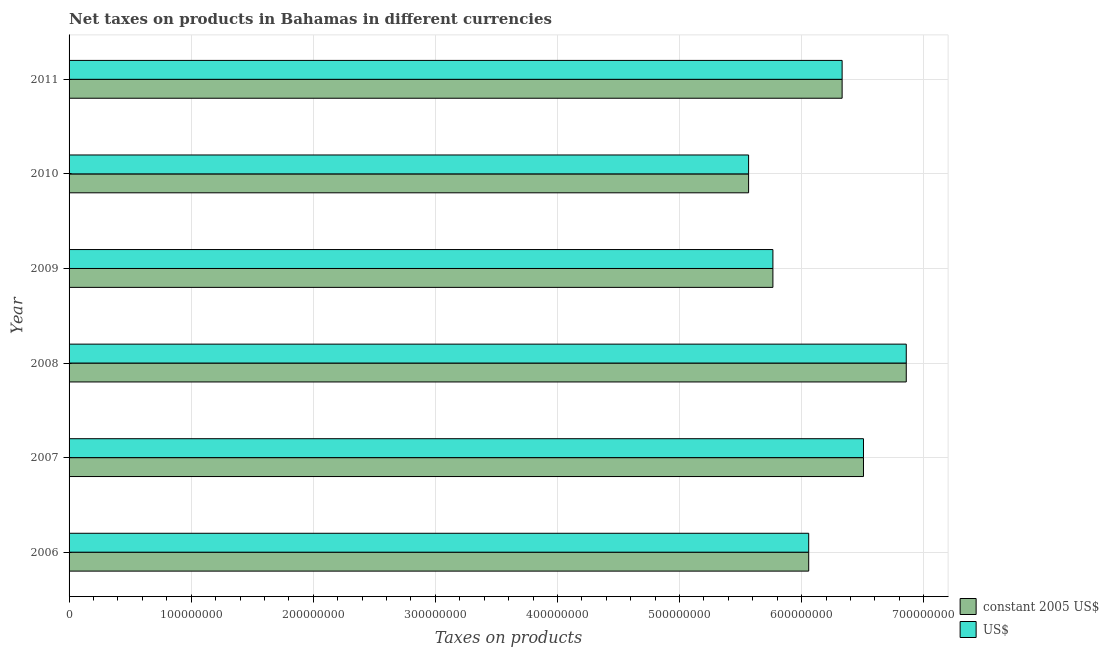Are the number of bars on each tick of the Y-axis equal?
Provide a succinct answer. Yes. How many bars are there on the 6th tick from the top?
Ensure brevity in your answer.  2. How many bars are there on the 3rd tick from the bottom?
Provide a succinct answer. 2. What is the net taxes in constant 2005 us$ in 2007?
Make the answer very short. 6.51e+08. Across all years, what is the maximum net taxes in us$?
Your response must be concise. 6.86e+08. Across all years, what is the minimum net taxes in us$?
Make the answer very short. 5.57e+08. In which year was the net taxes in us$ maximum?
Your answer should be compact. 2008. In which year was the net taxes in us$ minimum?
Keep it short and to the point. 2010. What is the total net taxes in constant 2005 us$ in the graph?
Your answer should be very brief. 3.71e+09. What is the difference between the net taxes in constant 2005 us$ in 2010 and that in 2011?
Offer a very short reply. -7.66e+07. What is the difference between the net taxes in us$ in 2008 and the net taxes in constant 2005 us$ in 2007?
Keep it short and to the point. 3.50e+07. What is the average net taxes in constant 2005 us$ per year?
Your answer should be very brief. 6.18e+08. What is the ratio of the net taxes in constant 2005 us$ in 2006 to that in 2007?
Your answer should be very brief. 0.93. Is the net taxes in us$ in 2008 less than that in 2009?
Your answer should be compact. No. Is the difference between the net taxes in us$ in 2009 and 2010 greater than the difference between the net taxes in constant 2005 us$ in 2009 and 2010?
Ensure brevity in your answer.  No. What is the difference between the highest and the second highest net taxes in us$?
Keep it short and to the point. 3.50e+07. What is the difference between the highest and the lowest net taxes in constant 2005 us$?
Ensure brevity in your answer.  1.29e+08. Is the sum of the net taxes in us$ in 2006 and 2007 greater than the maximum net taxes in constant 2005 us$ across all years?
Your answer should be compact. Yes. What does the 1st bar from the top in 2008 represents?
Ensure brevity in your answer.  US$. What does the 2nd bar from the bottom in 2006 represents?
Provide a succinct answer. US$. How many bars are there?
Your response must be concise. 12. How many years are there in the graph?
Ensure brevity in your answer.  6. What is the difference between two consecutive major ticks on the X-axis?
Offer a very short reply. 1.00e+08. Are the values on the major ticks of X-axis written in scientific E-notation?
Your answer should be very brief. No. Does the graph contain grids?
Keep it short and to the point. Yes. How many legend labels are there?
Provide a succinct answer. 2. What is the title of the graph?
Offer a terse response. Net taxes on products in Bahamas in different currencies. What is the label or title of the X-axis?
Provide a short and direct response. Taxes on products. What is the Taxes on products of constant 2005 US$ in 2006?
Offer a very short reply. 6.06e+08. What is the Taxes on products in US$ in 2006?
Give a very brief answer. 6.06e+08. What is the Taxes on products of constant 2005 US$ in 2007?
Make the answer very short. 6.51e+08. What is the Taxes on products of US$ in 2007?
Provide a succinct answer. 6.51e+08. What is the Taxes on products in constant 2005 US$ in 2008?
Ensure brevity in your answer.  6.86e+08. What is the Taxes on products of US$ in 2008?
Your answer should be very brief. 6.86e+08. What is the Taxes on products in constant 2005 US$ in 2009?
Give a very brief answer. 5.76e+08. What is the Taxes on products of US$ in 2009?
Ensure brevity in your answer.  5.76e+08. What is the Taxes on products in constant 2005 US$ in 2010?
Provide a short and direct response. 5.57e+08. What is the Taxes on products of US$ in 2010?
Your response must be concise. 5.57e+08. What is the Taxes on products of constant 2005 US$ in 2011?
Your answer should be compact. 6.33e+08. What is the Taxes on products in US$ in 2011?
Keep it short and to the point. 6.33e+08. Across all years, what is the maximum Taxes on products of constant 2005 US$?
Offer a terse response. 6.86e+08. Across all years, what is the maximum Taxes on products in US$?
Ensure brevity in your answer.  6.86e+08. Across all years, what is the minimum Taxes on products in constant 2005 US$?
Your answer should be compact. 5.57e+08. Across all years, what is the minimum Taxes on products in US$?
Make the answer very short. 5.57e+08. What is the total Taxes on products of constant 2005 US$ in the graph?
Keep it short and to the point. 3.71e+09. What is the total Taxes on products of US$ in the graph?
Give a very brief answer. 3.71e+09. What is the difference between the Taxes on products in constant 2005 US$ in 2006 and that in 2007?
Give a very brief answer. -4.49e+07. What is the difference between the Taxes on products in US$ in 2006 and that in 2007?
Your answer should be very brief. -4.49e+07. What is the difference between the Taxes on products in constant 2005 US$ in 2006 and that in 2008?
Your answer should be very brief. -7.99e+07. What is the difference between the Taxes on products of US$ in 2006 and that in 2008?
Provide a succinct answer. -7.99e+07. What is the difference between the Taxes on products of constant 2005 US$ in 2006 and that in 2009?
Your answer should be very brief. 2.93e+07. What is the difference between the Taxes on products in US$ in 2006 and that in 2009?
Give a very brief answer. 2.93e+07. What is the difference between the Taxes on products in constant 2005 US$ in 2006 and that in 2010?
Your response must be concise. 4.92e+07. What is the difference between the Taxes on products of US$ in 2006 and that in 2010?
Give a very brief answer. 4.92e+07. What is the difference between the Taxes on products in constant 2005 US$ in 2006 and that in 2011?
Make the answer very short. -2.74e+07. What is the difference between the Taxes on products of US$ in 2006 and that in 2011?
Offer a very short reply. -2.74e+07. What is the difference between the Taxes on products of constant 2005 US$ in 2007 and that in 2008?
Offer a terse response. -3.50e+07. What is the difference between the Taxes on products of US$ in 2007 and that in 2008?
Your answer should be very brief. -3.50e+07. What is the difference between the Taxes on products of constant 2005 US$ in 2007 and that in 2009?
Ensure brevity in your answer.  7.42e+07. What is the difference between the Taxes on products of US$ in 2007 and that in 2009?
Offer a very short reply. 7.42e+07. What is the difference between the Taxes on products in constant 2005 US$ in 2007 and that in 2010?
Give a very brief answer. 9.41e+07. What is the difference between the Taxes on products of US$ in 2007 and that in 2010?
Your answer should be compact. 9.41e+07. What is the difference between the Taxes on products of constant 2005 US$ in 2007 and that in 2011?
Provide a succinct answer. 1.75e+07. What is the difference between the Taxes on products of US$ in 2007 and that in 2011?
Offer a terse response. 1.75e+07. What is the difference between the Taxes on products of constant 2005 US$ in 2008 and that in 2009?
Provide a succinct answer. 1.09e+08. What is the difference between the Taxes on products in US$ in 2008 and that in 2009?
Keep it short and to the point. 1.09e+08. What is the difference between the Taxes on products of constant 2005 US$ in 2008 and that in 2010?
Your response must be concise. 1.29e+08. What is the difference between the Taxes on products of US$ in 2008 and that in 2010?
Your response must be concise. 1.29e+08. What is the difference between the Taxes on products in constant 2005 US$ in 2008 and that in 2011?
Make the answer very short. 5.25e+07. What is the difference between the Taxes on products of US$ in 2008 and that in 2011?
Give a very brief answer. 5.25e+07. What is the difference between the Taxes on products of constant 2005 US$ in 2009 and that in 2010?
Give a very brief answer. 1.99e+07. What is the difference between the Taxes on products in US$ in 2009 and that in 2010?
Keep it short and to the point. 1.99e+07. What is the difference between the Taxes on products in constant 2005 US$ in 2009 and that in 2011?
Offer a very short reply. -5.67e+07. What is the difference between the Taxes on products of US$ in 2009 and that in 2011?
Provide a succinct answer. -5.67e+07. What is the difference between the Taxes on products in constant 2005 US$ in 2010 and that in 2011?
Ensure brevity in your answer.  -7.66e+07. What is the difference between the Taxes on products in US$ in 2010 and that in 2011?
Provide a short and direct response. -7.66e+07. What is the difference between the Taxes on products of constant 2005 US$ in 2006 and the Taxes on products of US$ in 2007?
Give a very brief answer. -4.49e+07. What is the difference between the Taxes on products of constant 2005 US$ in 2006 and the Taxes on products of US$ in 2008?
Offer a very short reply. -7.99e+07. What is the difference between the Taxes on products of constant 2005 US$ in 2006 and the Taxes on products of US$ in 2009?
Make the answer very short. 2.93e+07. What is the difference between the Taxes on products of constant 2005 US$ in 2006 and the Taxes on products of US$ in 2010?
Provide a short and direct response. 4.92e+07. What is the difference between the Taxes on products of constant 2005 US$ in 2006 and the Taxes on products of US$ in 2011?
Offer a terse response. -2.74e+07. What is the difference between the Taxes on products of constant 2005 US$ in 2007 and the Taxes on products of US$ in 2008?
Make the answer very short. -3.50e+07. What is the difference between the Taxes on products of constant 2005 US$ in 2007 and the Taxes on products of US$ in 2009?
Your answer should be very brief. 7.42e+07. What is the difference between the Taxes on products in constant 2005 US$ in 2007 and the Taxes on products in US$ in 2010?
Provide a short and direct response. 9.41e+07. What is the difference between the Taxes on products in constant 2005 US$ in 2007 and the Taxes on products in US$ in 2011?
Make the answer very short. 1.75e+07. What is the difference between the Taxes on products in constant 2005 US$ in 2008 and the Taxes on products in US$ in 2009?
Give a very brief answer. 1.09e+08. What is the difference between the Taxes on products of constant 2005 US$ in 2008 and the Taxes on products of US$ in 2010?
Ensure brevity in your answer.  1.29e+08. What is the difference between the Taxes on products in constant 2005 US$ in 2008 and the Taxes on products in US$ in 2011?
Provide a short and direct response. 5.25e+07. What is the difference between the Taxes on products in constant 2005 US$ in 2009 and the Taxes on products in US$ in 2010?
Make the answer very short. 1.99e+07. What is the difference between the Taxes on products in constant 2005 US$ in 2009 and the Taxes on products in US$ in 2011?
Provide a short and direct response. -5.67e+07. What is the difference between the Taxes on products of constant 2005 US$ in 2010 and the Taxes on products of US$ in 2011?
Give a very brief answer. -7.66e+07. What is the average Taxes on products in constant 2005 US$ per year?
Your answer should be very brief. 6.18e+08. What is the average Taxes on products of US$ per year?
Provide a short and direct response. 6.18e+08. In the year 2006, what is the difference between the Taxes on products in constant 2005 US$ and Taxes on products in US$?
Ensure brevity in your answer.  0. In the year 2010, what is the difference between the Taxes on products of constant 2005 US$ and Taxes on products of US$?
Provide a short and direct response. 0. In the year 2011, what is the difference between the Taxes on products of constant 2005 US$ and Taxes on products of US$?
Provide a short and direct response. 0. What is the ratio of the Taxes on products of constant 2005 US$ in 2006 to that in 2007?
Your answer should be compact. 0.93. What is the ratio of the Taxes on products of US$ in 2006 to that in 2007?
Provide a short and direct response. 0.93. What is the ratio of the Taxes on products of constant 2005 US$ in 2006 to that in 2008?
Provide a succinct answer. 0.88. What is the ratio of the Taxes on products in US$ in 2006 to that in 2008?
Provide a succinct answer. 0.88. What is the ratio of the Taxes on products of constant 2005 US$ in 2006 to that in 2009?
Offer a terse response. 1.05. What is the ratio of the Taxes on products in US$ in 2006 to that in 2009?
Offer a very short reply. 1.05. What is the ratio of the Taxes on products of constant 2005 US$ in 2006 to that in 2010?
Provide a succinct answer. 1.09. What is the ratio of the Taxes on products of US$ in 2006 to that in 2010?
Provide a succinct answer. 1.09. What is the ratio of the Taxes on products in constant 2005 US$ in 2006 to that in 2011?
Provide a succinct answer. 0.96. What is the ratio of the Taxes on products of US$ in 2006 to that in 2011?
Make the answer very short. 0.96. What is the ratio of the Taxes on products of constant 2005 US$ in 2007 to that in 2008?
Ensure brevity in your answer.  0.95. What is the ratio of the Taxes on products in US$ in 2007 to that in 2008?
Your response must be concise. 0.95. What is the ratio of the Taxes on products in constant 2005 US$ in 2007 to that in 2009?
Provide a short and direct response. 1.13. What is the ratio of the Taxes on products in US$ in 2007 to that in 2009?
Make the answer very short. 1.13. What is the ratio of the Taxes on products in constant 2005 US$ in 2007 to that in 2010?
Your answer should be very brief. 1.17. What is the ratio of the Taxes on products in US$ in 2007 to that in 2010?
Offer a very short reply. 1.17. What is the ratio of the Taxes on products of constant 2005 US$ in 2007 to that in 2011?
Ensure brevity in your answer.  1.03. What is the ratio of the Taxes on products of US$ in 2007 to that in 2011?
Offer a very short reply. 1.03. What is the ratio of the Taxes on products in constant 2005 US$ in 2008 to that in 2009?
Your response must be concise. 1.19. What is the ratio of the Taxes on products of US$ in 2008 to that in 2009?
Your response must be concise. 1.19. What is the ratio of the Taxes on products of constant 2005 US$ in 2008 to that in 2010?
Make the answer very short. 1.23. What is the ratio of the Taxes on products in US$ in 2008 to that in 2010?
Your answer should be very brief. 1.23. What is the ratio of the Taxes on products in constant 2005 US$ in 2008 to that in 2011?
Ensure brevity in your answer.  1.08. What is the ratio of the Taxes on products in US$ in 2008 to that in 2011?
Provide a short and direct response. 1.08. What is the ratio of the Taxes on products in constant 2005 US$ in 2009 to that in 2010?
Offer a terse response. 1.04. What is the ratio of the Taxes on products of US$ in 2009 to that in 2010?
Your answer should be compact. 1.04. What is the ratio of the Taxes on products of constant 2005 US$ in 2009 to that in 2011?
Your answer should be compact. 0.91. What is the ratio of the Taxes on products in US$ in 2009 to that in 2011?
Make the answer very short. 0.91. What is the ratio of the Taxes on products of constant 2005 US$ in 2010 to that in 2011?
Ensure brevity in your answer.  0.88. What is the ratio of the Taxes on products in US$ in 2010 to that in 2011?
Make the answer very short. 0.88. What is the difference between the highest and the second highest Taxes on products of constant 2005 US$?
Offer a terse response. 3.50e+07. What is the difference between the highest and the second highest Taxes on products of US$?
Ensure brevity in your answer.  3.50e+07. What is the difference between the highest and the lowest Taxes on products of constant 2005 US$?
Offer a very short reply. 1.29e+08. What is the difference between the highest and the lowest Taxes on products in US$?
Offer a very short reply. 1.29e+08. 